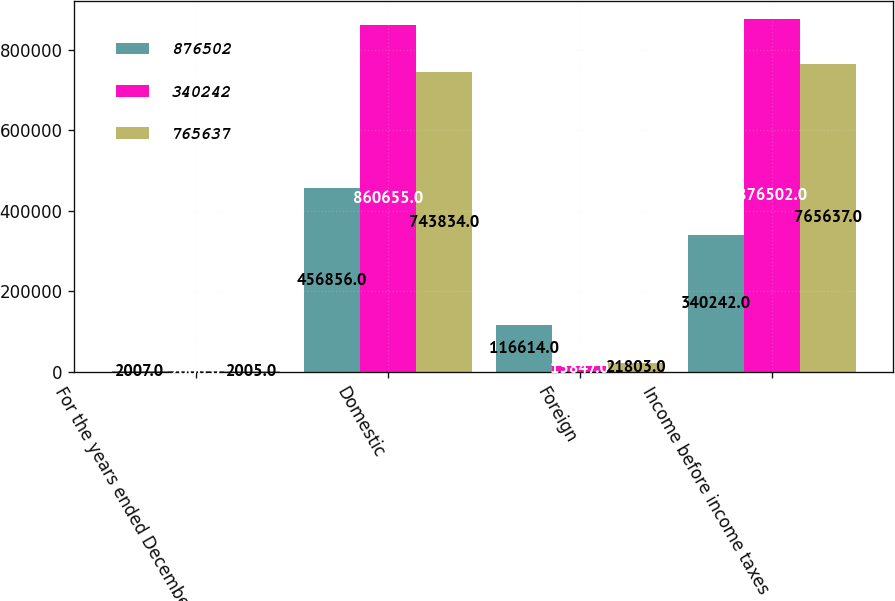Convert chart to OTSL. <chart><loc_0><loc_0><loc_500><loc_500><stacked_bar_chart><ecel><fcel>For the years ended December<fcel>Domestic<fcel>Foreign<fcel>Income before income taxes<nl><fcel>876502<fcel>2007<fcel>456856<fcel>116614<fcel>340242<nl><fcel>340242<fcel>2006<fcel>860655<fcel>15847<fcel>876502<nl><fcel>765637<fcel>2005<fcel>743834<fcel>21803<fcel>765637<nl></chart> 